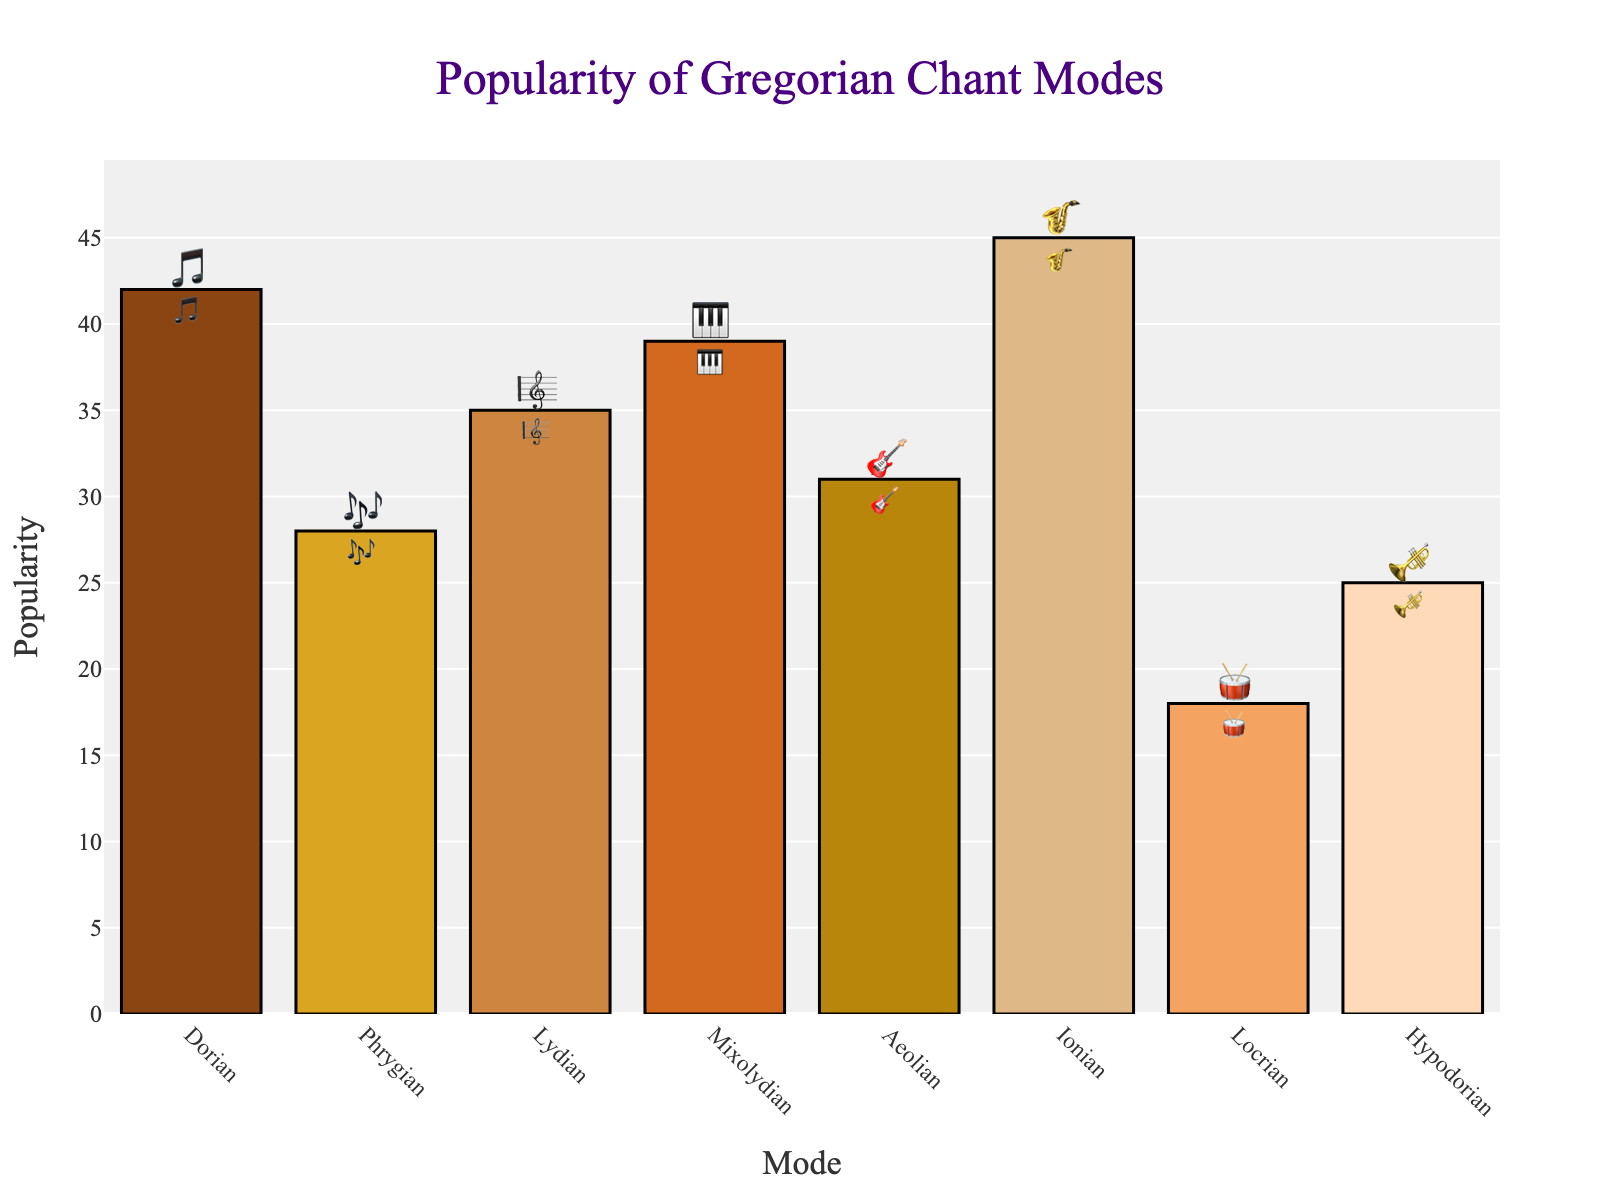What is the title of the chart? The title is positioned at the center and top of the chart. It says "Popularity of Gregorian Chant Modes".
Answer: Popularity of Gregorian Chant Modes Which mode has the highest popularity and what emoji represents it? The tallest bar represents the highest popularity. The "Ionian" mode has the highest popularity with a "🎷" emoji.
Answer: Ionian, 🎷 What is the popularity of the Dorian mode? Look for the Dorian bar and check the y-axis value aligned with the top of the bar. The popularity of the Dorian mode is 42.
Answer: 42 What is the combined popularity of Mixolydian and Phrygian modes? Add the popularity values of Mixolydian (39) and Phrygian (28), which results in 39 + 28 = 67.
Answer: 67 Which mode is the least popular? The shortest bar indicates the least popularity. The "Locrian" mode is the least popular with 18.
Answer: Locrian How many modes have a popularity value greater than 30? Count the number of bars that extend above the y-axis value of 30. Dorian (42), Lydian (35), Mixolydian (39), Aeolian (31), Ionian (45) means 5 modes.
Answer: 5 What is the difference in popularity between the Ionian and Aeolian modes? Subtract the popularity value of Aeolian (31) from Ionian (45). The difference is 45 - 31 = 14.
Answer: 14 Which mode represented by the "🎶" emoji, and what is its popularity? "🎶" emoji is associated with "Phrygian". The popularity value for the Phrygian mode is 28.
Answer: Phrygian, 28 Which mode has nearly the same popularity as Aeolian and what is the difference between them? Find a bar with a value close to Aeolian’s 31. Hypodorian has 25. The difference is 31 - 25 = 6.
Answer: Hypodorian, 6 Name all the modes with a popularity between 25 and 40. Identify all bars between 25 and 40 on the y-axis; these are Phrygian (28), Lydian (35), Mixolydian (39), Aeolian (31), and Hypodorian (25).
Answer: Phrygian, Lydian, Mixolydian, Aeolian, Hypodorian 